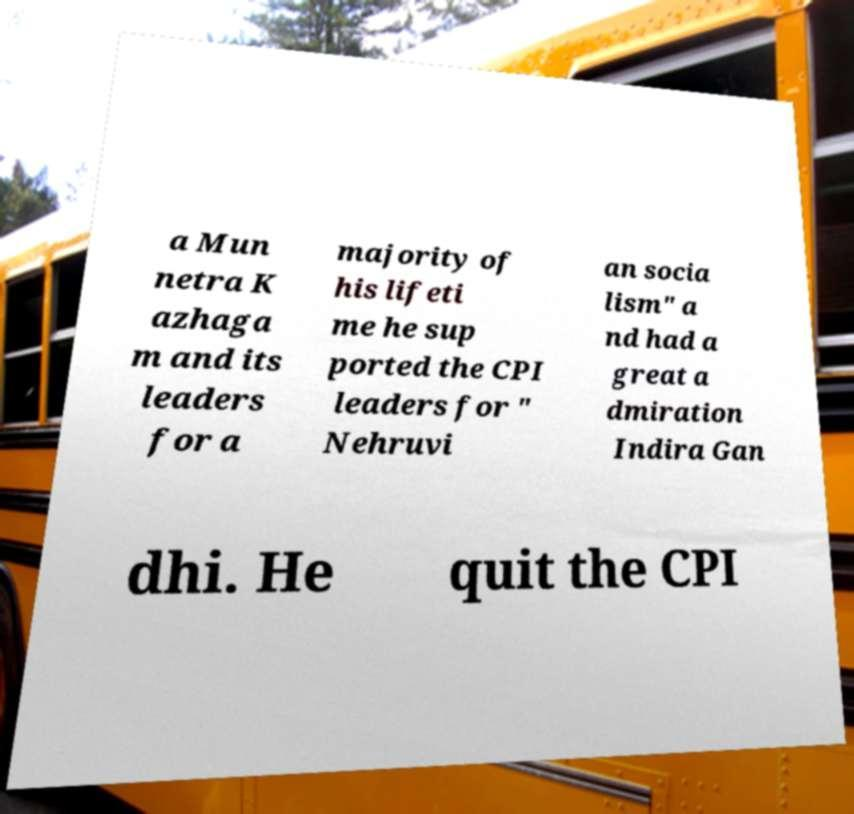Can you read and provide the text displayed in the image?This photo seems to have some interesting text. Can you extract and type it out for me? a Mun netra K azhaga m and its leaders for a majority of his lifeti me he sup ported the CPI leaders for " Nehruvi an socia lism" a nd had a great a dmiration Indira Gan dhi. He quit the CPI 